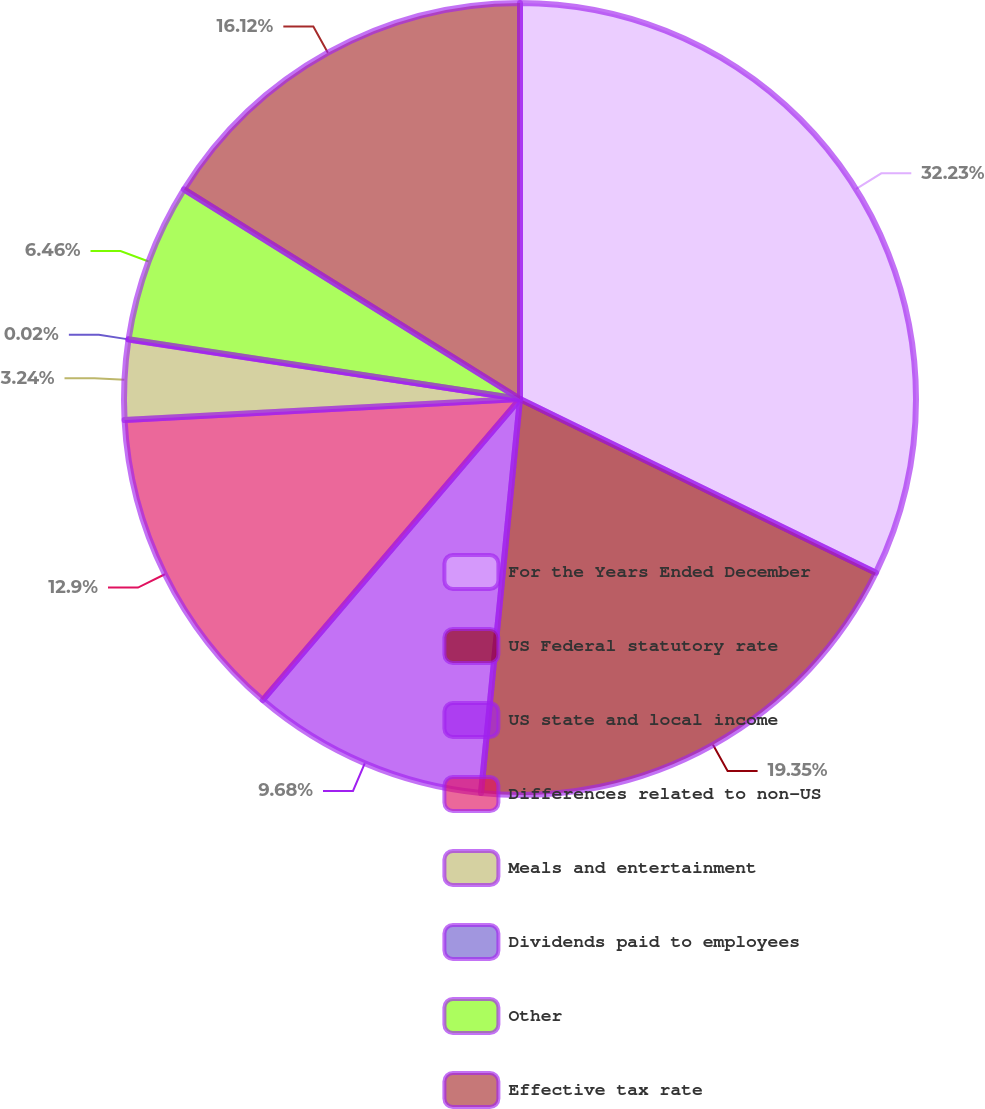Convert chart to OTSL. <chart><loc_0><loc_0><loc_500><loc_500><pie_chart><fcel>For the Years Ended December<fcel>US Federal statutory rate<fcel>US state and local income<fcel>Differences related to non-US<fcel>Meals and entertainment<fcel>Dividends paid to employees<fcel>Other<fcel>Effective tax rate<nl><fcel>32.22%<fcel>19.34%<fcel>9.68%<fcel>12.9%<fcel>3.24%<fcel>0.02%<fcel>6.46%<fcel>16.12%<nl></chart> 